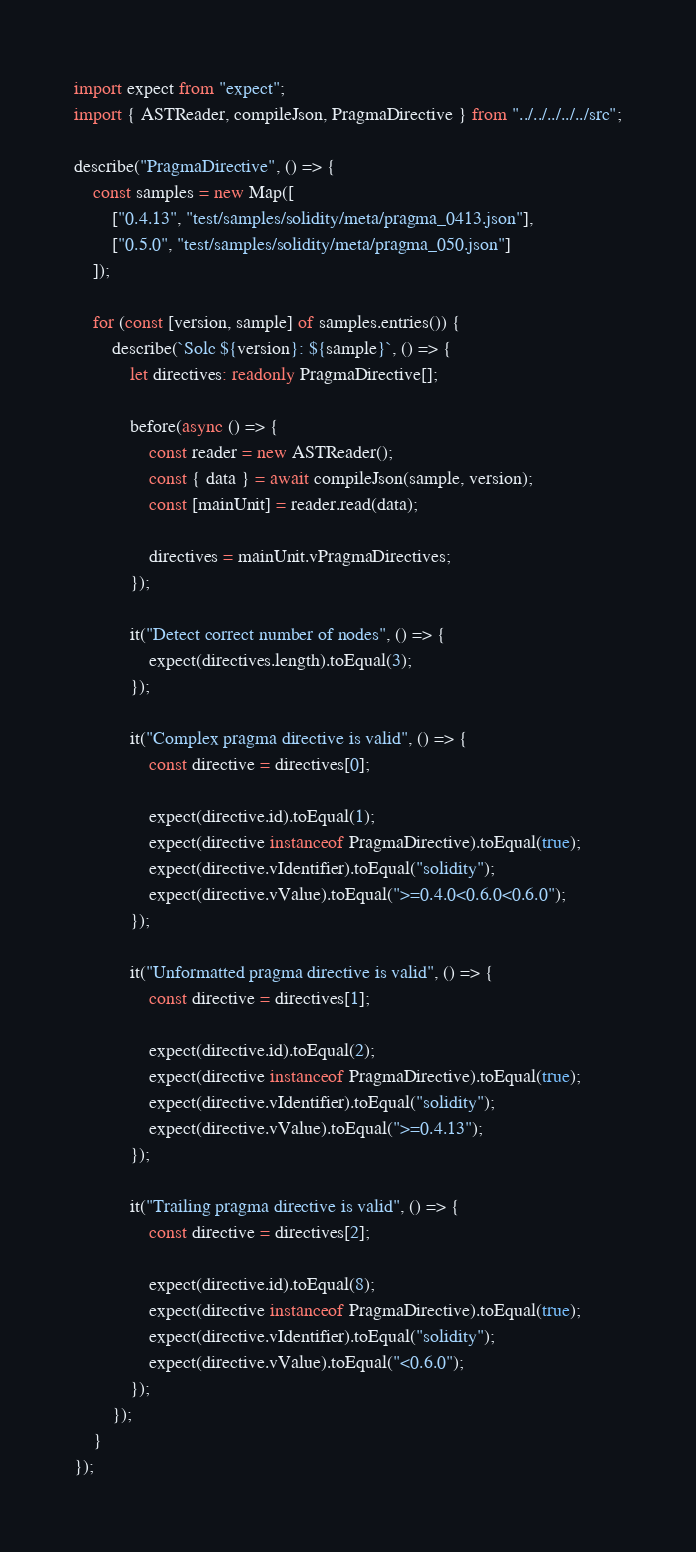<code> <loc_0><loc_0><loc_500><loc_500><_TypeScript_>import expect from "expect";
import { ASTReader, compileJson, PragmaDirective } from "../../../../../src";

describe("PragmaDirective", () => {
    const samples = new Map([
        ["0.4.13", "test/samples/solidity/meta/pragma_0413.json"],
        ["0.5.0", "test/samples/solidity/meta/pragma_050.json"]
    ]);

    for (const [version, sample] of samples.entries()) {
        describe(`Solc ${version}: ${sample}`, () => {
            let directives: readonly PragmaDirective[];

            before(async () => {
                const reader = new ASTReader();
                const { data } = await compileJson(sample, version);
                const [mainUnit] = reader.read(data);

                directives = mainUnit.vPragmaDirectives;
            });

            it("Detect correct number of nodes", () => {
                expect(directives.length).toEqual(3);
            });

            it("Complex pragma directive is valid", () => {
                const directive = directives[0];

                expect(directive.id).toEqual(1);
                expect(directive instanceof PragmaDirective).toEqual(true);
                expect(directive.vIdentifier).toEqual("solidity");
                expect(directive.vValue).toEqual(">=0.4.0<0.6.0<0.6.0");
            });

            it("Unformatted pragma directive is valid", () => {
                const directive = directives[1];

                expect(directive.id).toEqual(2);
                expect(directive instanceof PragmaDirective).toEqual(true);
                expect(directive.vIdentifier).toEqual("solidity");
                expect(directive.vValue).toEqual(">=0.4.13");
            });

            it("Trailing pragma directive is valid", () => {
                const directive = directives[2];

                expect(directive.id).toEqual(8);
                expect(directive instanceof PragmaDirective).toEqual(true);
                expect(directive.vIdentifier).toEqual("solidity");
                expect(directive.vValue).toEqual("<0.6.0");
            });
        });
    }
});
</code> 